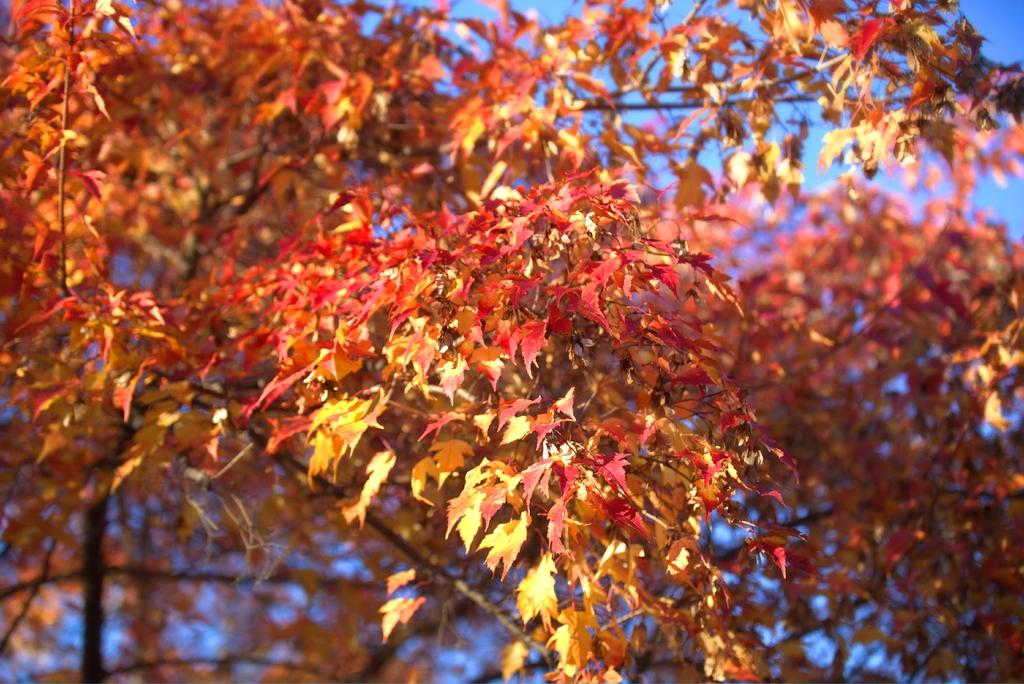What type of vegetation can be seen in the image? There are trees in the image. What part of the natural environment is visible in the image? The sky is visible in the background of the image. What type of nut is being cracked by the horse in the image? There is no horse or nut present in the image; it only features trees and the sky. 